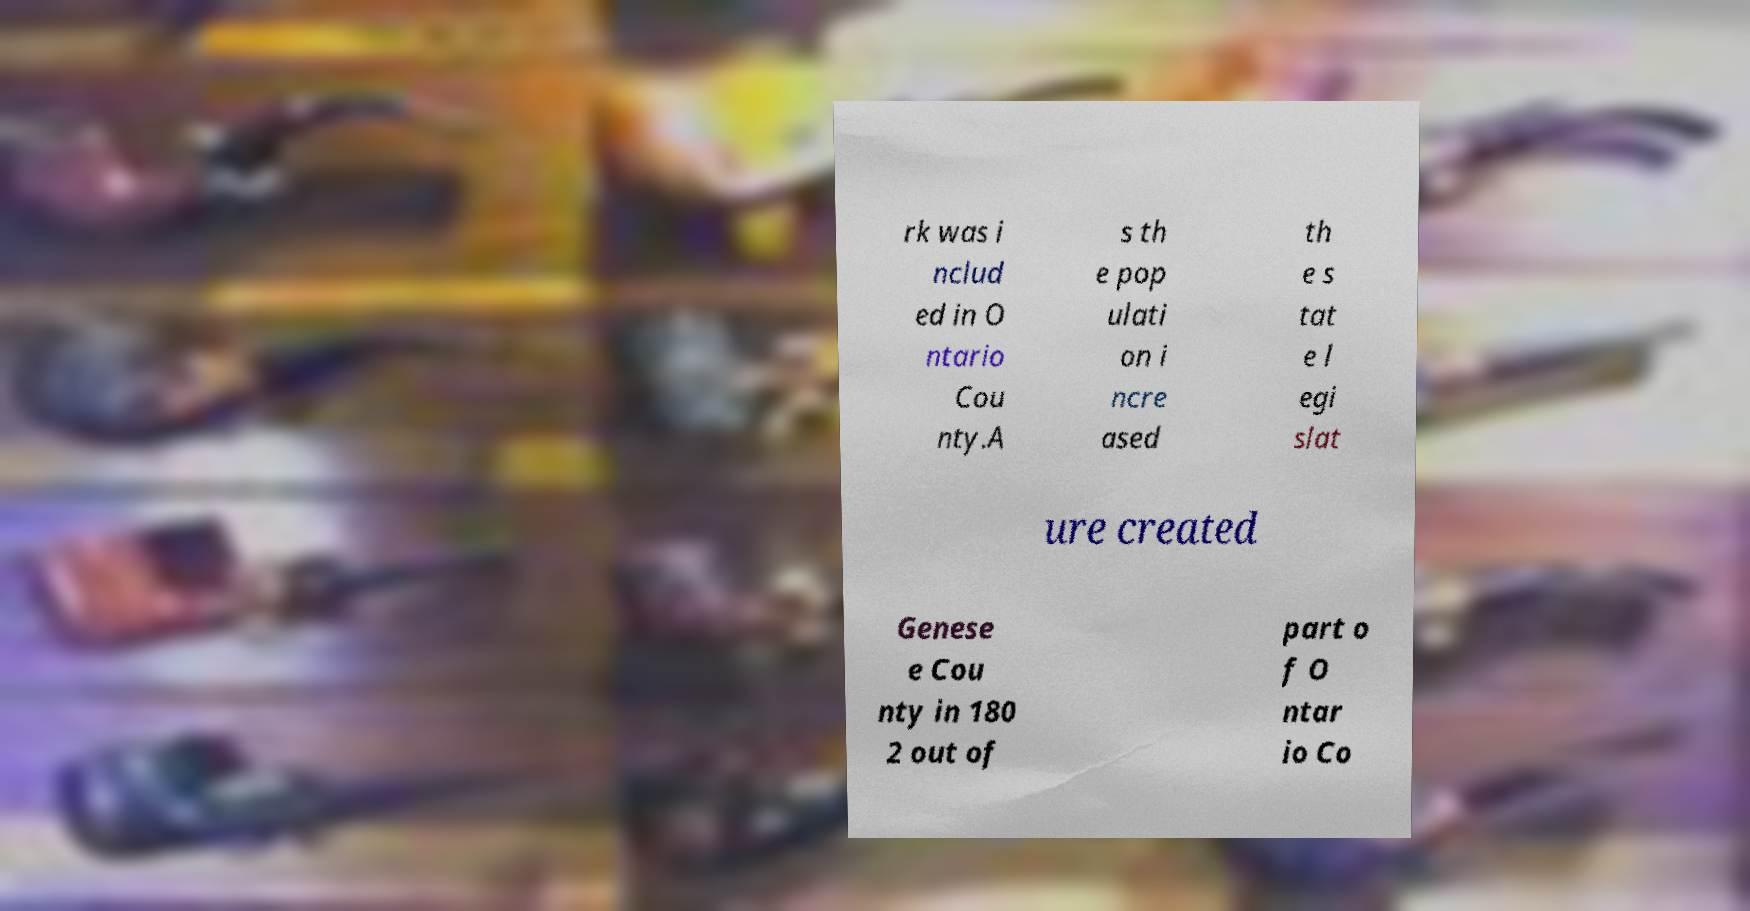Could you assist in decoding the text presented in this image and type it out clearly? rk was i nclud ed in O ntario Cou nty.A s th e pop ulati on i ncre ased th e s tat e l egi slat ure created Genese e Cou nty in 180 2 out of part o f O ntar io Co 